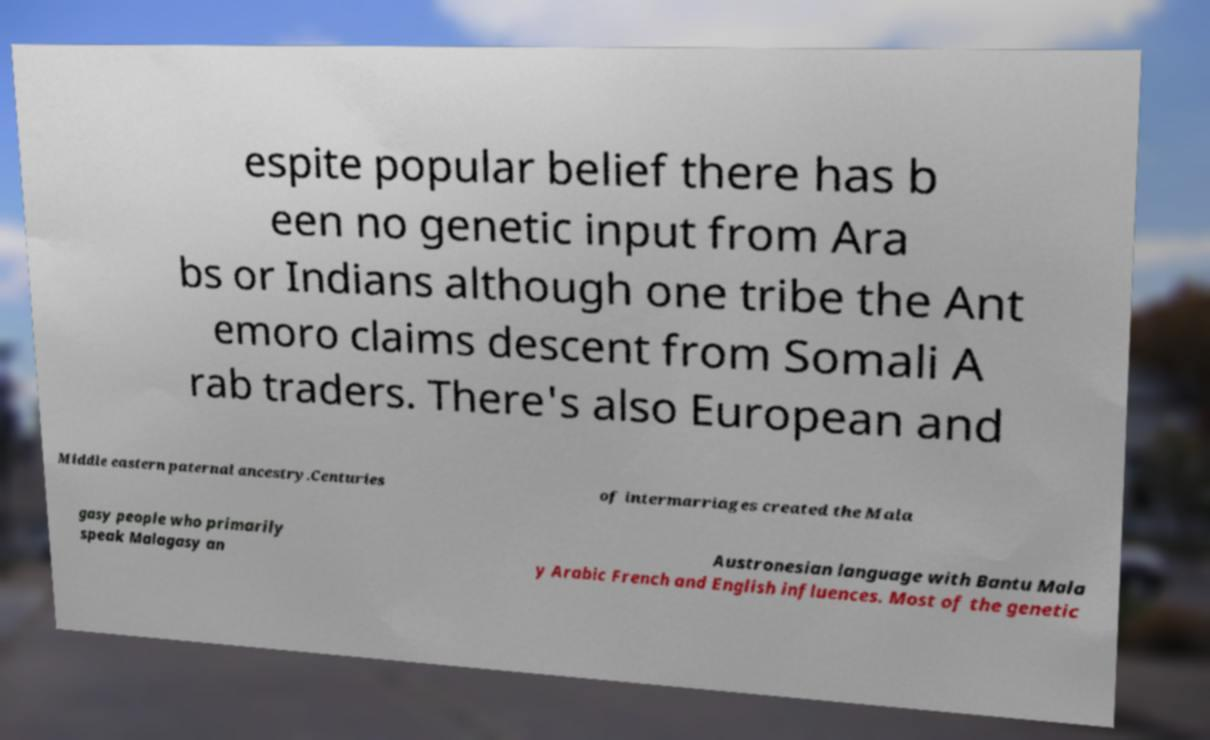Could you assist in decoding the text presented in this image and type it out clearly? espite popular belief there has b een no genetic input from Ara bs or Indians although one tribe the Ant emoro claims descent from Somali A rab traders. There's also European and Middle eastern paternal ancestry.Centuries of intermarriages created the Mala gasy people who primarily speak Malagasy an Austronesian language with Bantu Mala y Arabic French and English influences. Most of the genetic 